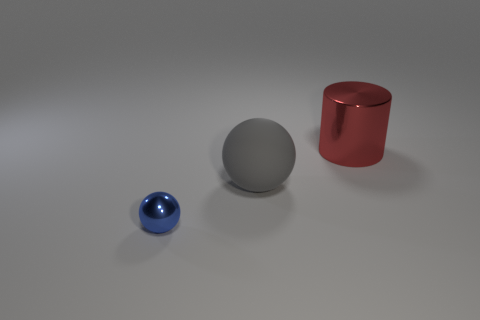Add 2 large gray things. How many objects exist? 5 Subtract all cylinders. How many objects are left? 2 Add 2 shiny spheres. How many shiny spheres are left? 3 Add 3 large purple balls. How many large purple balls exist? 3 Subtract 0 green cubes. How many objects are left? 3 Subtract all gray shiny spheres. Subtract all metal cylinders. How many objects are left? 2 